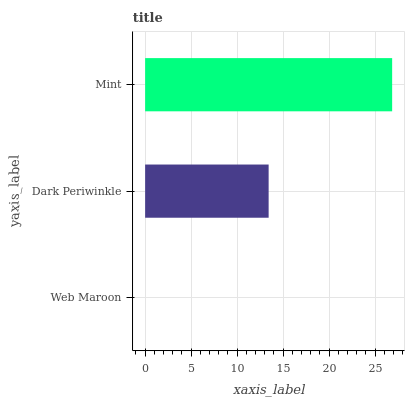Is Web Maroon the minimum?
Answer yes or no. Yes. Is Mint the maximum?
Answer yes or no. Yes. Is Dark Periwinkle the minimum?
Answer yes or no. No. Is Dark Periwinkle the maximum?
Answer yes or no. No. Is Dark Periwinkle greater than Web Maroon?
Answer yes or no. Yes. Is Web Maroon less than Dark Periwinkle?
Answer yes or no. Yes. Is Web Maroon greater than Dark Periwinkle?
Answer yes or no. No. Is Dark Periwinkle less than Web Maroon?
Answer yes or no. No. Is Dark Periwinkle the high median?
Answer yes or no. Yes. Is Dark Periwinkle the low median?
Answer yes or no. Yes. Is Mint the high median?
Answer yes or no. No. Is Mint the low median?
Answer yes or no. No. 